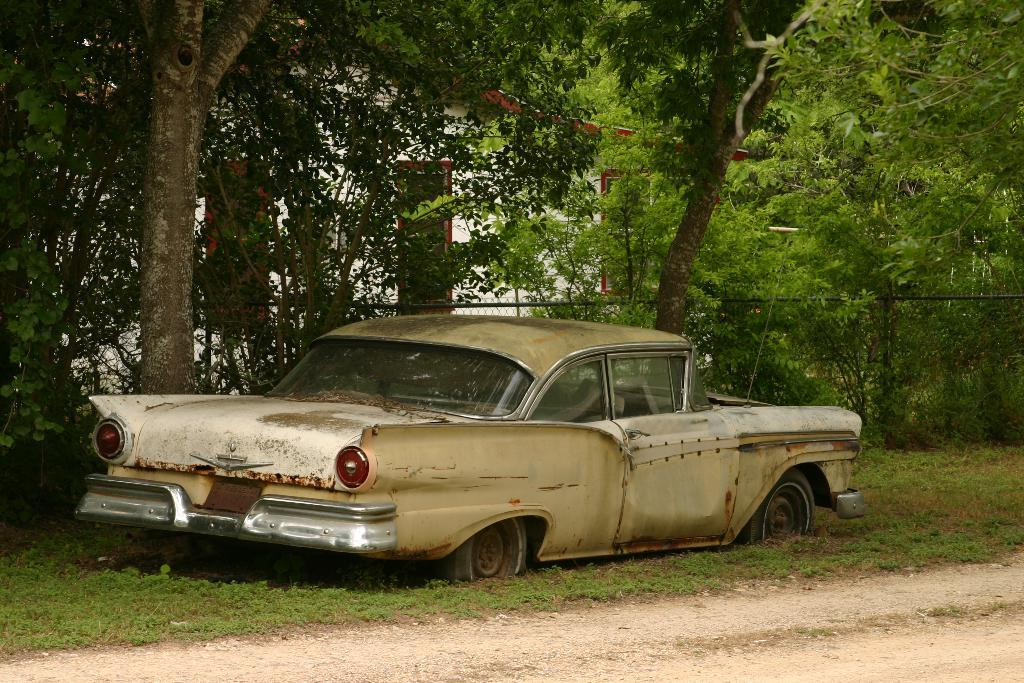What is the main object on the grass in the image? There is a car on the grass in the image. What type of natural elements can be seen in the image? There are trees visible in the image. What type of barrier is present in the image? There is fencing in the image. What type of building is visible in the image? There is a house in the image. Can you hear the cactus laughing in the image? There is no cactus present in the image, and therefore it cannot be heard laughing. 